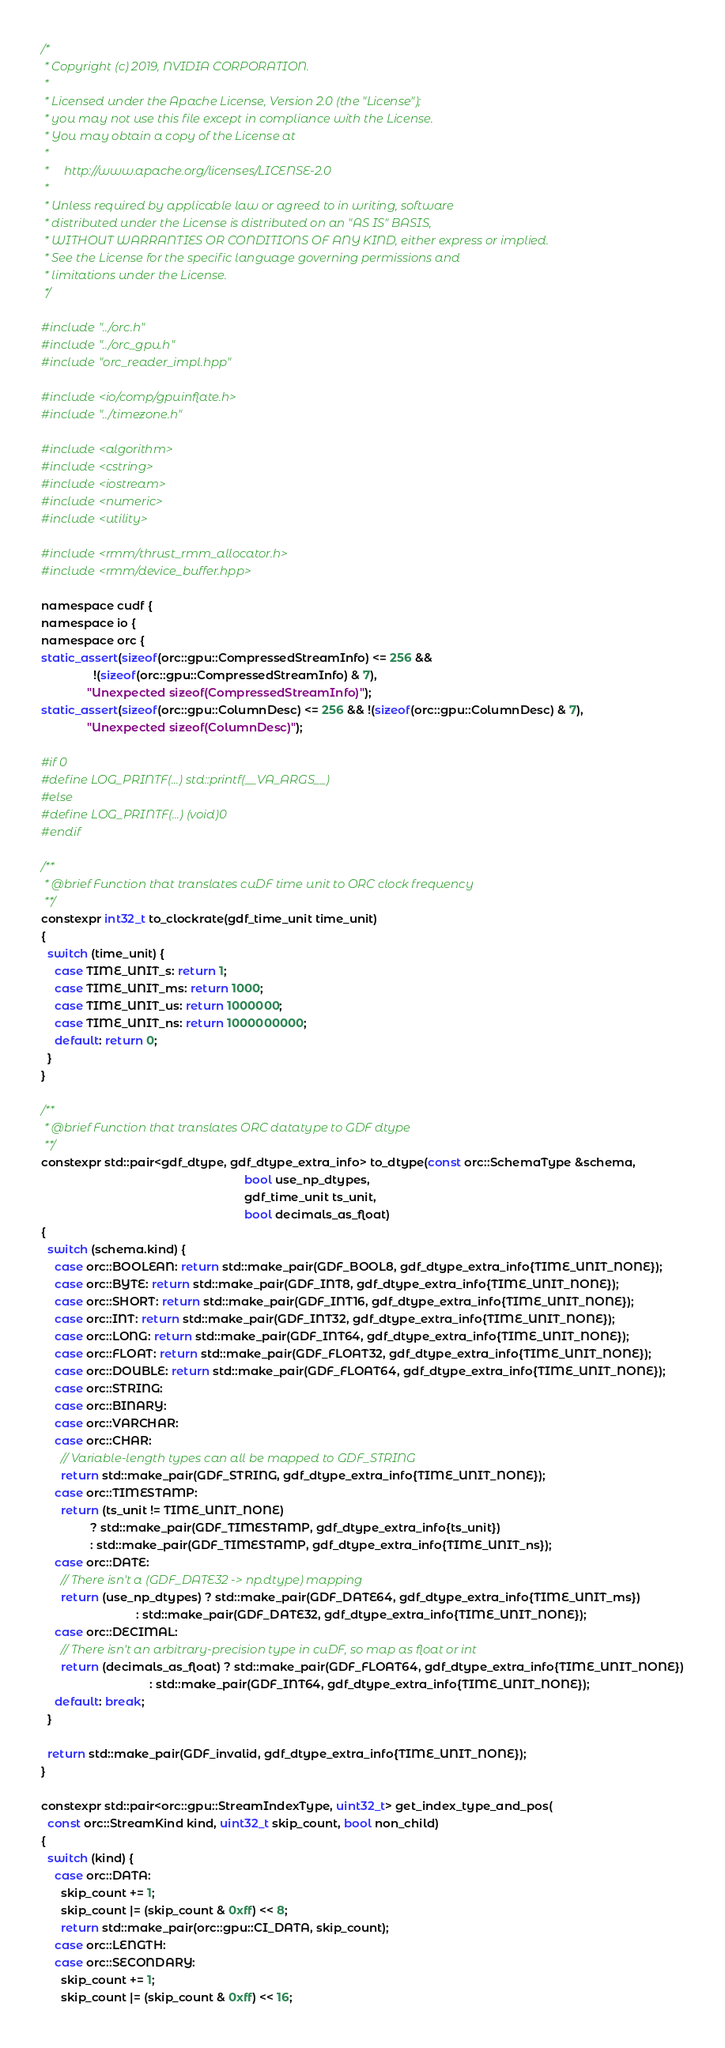<code> <loc_0><loc_0><loc_500><loc_500><_Cuda_>/*
 * Copyright (c) 2019, NVIDIA CORPORATION.
 *
 * Licensed under the Apache License, Version 2.0 (the "License");
 * you may not use this file except in compliance with the License.
 * You may obtain a copy of the License at
 *
 *     http://www.apache.org/licenses/LICENSE-2.0
 *
 * Unless required by applicable law or agreed to in writing, software
 * distributed under the License is distributed on an "AS IS" BASIS,
 * WITHOUT WARRANTIES OR CONDITIONS OF ANY KIND, either express or implied.
 * See the License for the specific language governing permissions and
 * limitations under the License.
 */

#include "../orc.h"
#include "../orc_gpu.h"
#include "orc_reader_impl.hpp"

#include <io/comp/gpuinflate.h>
#include "../timezone.h"

#include <algorithm>
#include <cstring>
#include <iostream>
#include <numeric>
#include <utility>

#include <rmm/thrust_rmm_allocator.h>
#include <rmm/device_buffer.hpp>

namespace cudf {
namespace io {
namespace orc {
static_assert(sizeof(orc::gpu::CompressedStreamInfo) <= 256 &&
                !(sizeof(orc::gpu::CompressedStreamInfo) & 7),
              "Unexpected sizeof(CompressedStreamInfo)");
static_assert(sizeof(orc::gpu::ColumnDesc) <= 256 && !(sizeof(orc::gpu::ColumnDesc) & 7),
              "Unexpected sizeof(ColumnDesc)");

#if 0
#define LOG_PRINTF(...) std::printf(__VA_ARGS__)
#else
#define LOG_PRINTF(...) (void)0
#endif

/**
 * @brief Function that translates cuDF time unit to ORC clock frequency
 **/
constexpr int32_t to_clockrate(gdf_time_unit time_unit)
{
  switch (time_unit) {
    case TIME_UNIT_s: return 1;
    case TIME_UNIT_ms: return 1000;
    case TIME_UNIT_us: return 1000000;
    case TIME_UNIT_ns: return 1000000000;
    default: return 0;
  }
}

/**
 * @brief Function that translates ORC datatype to GDF dtype
 **/
constexpr std::pair<gdf_dtype, gdf_dtype_extra_info> to_dtype(const orc::SchemaType &schema,
                                                              bool use_np_dtypes,
                                                              gdf_time_unit ts_unit,
                                                              bool decimals_as_float)
{
  switch (schema.kind) {
    case orc::BOOLEAN: return std::make_pair(GDF_BOOL8, gdf_dtype_extra_info{TIME_UNIT_NONE});
    case orc::BYTE: return std::make_pair(GDF_INT8, gdf_dtype_extra_info{TIME_UNIT_NONE});
    case orc::SHORT: return std::make_pair(GDF_INT16, gdf_dtype_extra_info{TIME_UNIT_NONE});
    case orc::INT: return std::make_pair(GDF_INT32, gdf_dtype_extra_info{TIME_UNIT_NONE});
    case orc::LONG: return std::make_pair(GDF_INT64, gdf_dtype_extra_info{TIME_UNIT_NONE});
    case orc::FLOAT: return std::make_pair(GDF_FLOAT32, gdf_dtype_extra_info{TIME_UNIT_NONE});
    case orc::DOUBLE: return std::make_pair(GDF_FLOAT64, gdf_dtype_extra_info{TIME_UNIT_NONE});
    case orc::STRING:
    case orc::BINARY:
    case orc::VARCHAR:
    case orc::CHAR:
      // Variable-length types can all be mapped to GDF_STRING
      return std::make_pair(GDF_STRING, gdf_dtype_extra_info{TIME_UNIT_NONE});
    case orc::TIMESTAMP:
      return (ts_unit != TIME_UNIT_NONE)
               ? std::make_pair(GDF_TIMESTAMP, gdf_dtype_extra_info{ts_unit})
               : std::make_pair(GDF_TIMESTAMP, gdf_dtype_extra_info{TIME_UNIT_ns});
    case orc::DATE:
      // There isn't a (GDF_DATE32 -> np.dtype) mapping
      return (use_np_dtypes) ? std::make_pair(GDF_DATE64, gdf_dtype_extra_info{TIME_UNIT_ms})
                             : std::make_pair(GDF_DATE32, gdf_dtype_extra_info{TIME_UNIT_NONE});
    case orc::DECIMAL:
      // There isn't an arbitrary-precision type in cuDF, so map as float or int
      return (decimals_as_float) ? std::make_pair(GDF_FLOAT64, gdf_dtype_extra_info{TIME_UNIT_NONE})
                                 : std::make_pair(GDF_INT64, gdf_dtype_extra_info{TIME_UNIT_NONE});
    default: break;
  }

  return std::make_pair(GDF_invalid, gdf_dtype_extra_info{TIME_UNIT_NONE});
}

constexpr std::pair<orc::gpu::StreamIndexType, uint32_t> get_index_type_and_pos(
  const orc::StreamKind kind, uint32_t skip_count, bool non_child)
{
  switch (kind) {
    case orc::DATA:
      skip_count += 1;
      skip_count |= (skip_count & 0xff) << 8;
      return std::make_pair(orc::gpu::CI_DATA, skip_count);
    case orc::LENGTH:
    case orc::SECONDARY:
      skip_count += 1;
      skip_count |= (skip_count & 0xff) << 16;</code> 